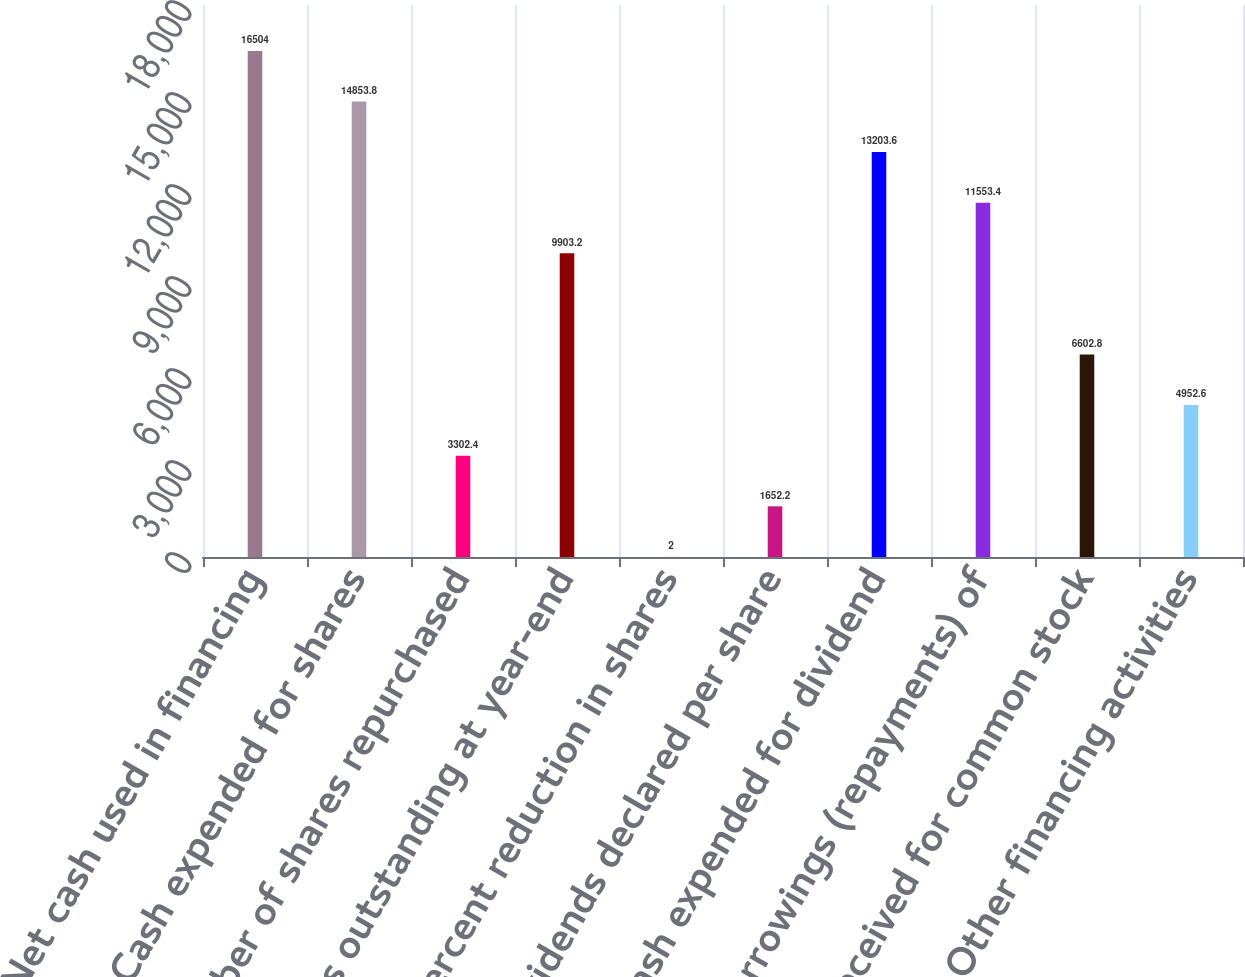<chart> <loc_0><loc_0><loc_500><loc_500><bar_chart><fcel>Net cash used in financing<fcel>Cash expended for shares<fcel>Number of shares repurchased<fcel>Shares outstanding at year-end<fcel>Percent reduction in shares<fcel>Dividends declared per share<fcel>Cash expended for dividend<fcel>Net borrowings (repayments) of<fcel>Cash received for common stock<fcel>Other financing activities<nl><fcel>16504<fcel>14853.8<fcel>3302.4<fcel>9903.2<fcel>2<fcel>1652.2<fcel>13203.6<fcel>11553.4<fcel>6602.8<fcel>4952.6<nl></chart> 